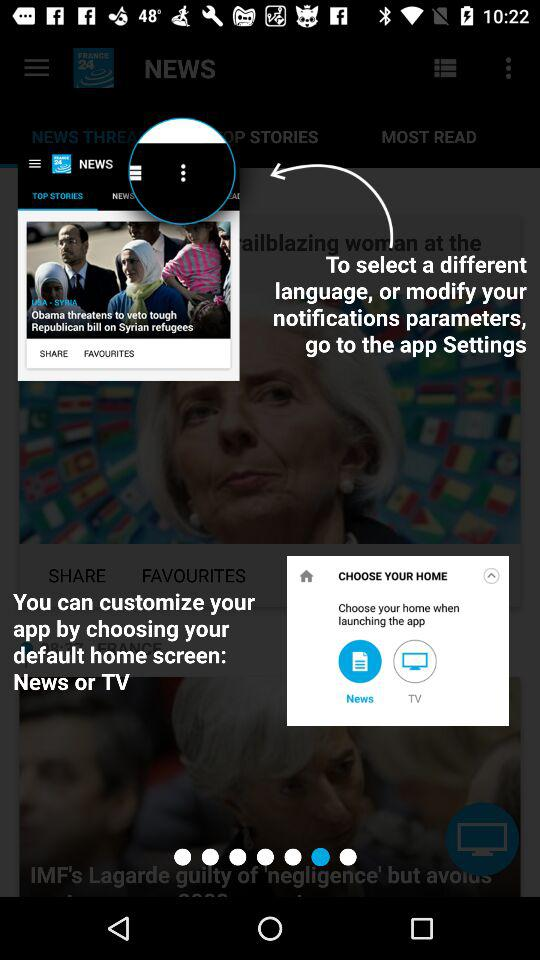How many home screens are there?
Answer the question using a single word or phrase. 2 